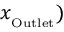Convert formula to latex. <formula><loc_0><loc_0><loc_500><loc_500>x _ { _ { O } u t l e t } )</formula> 